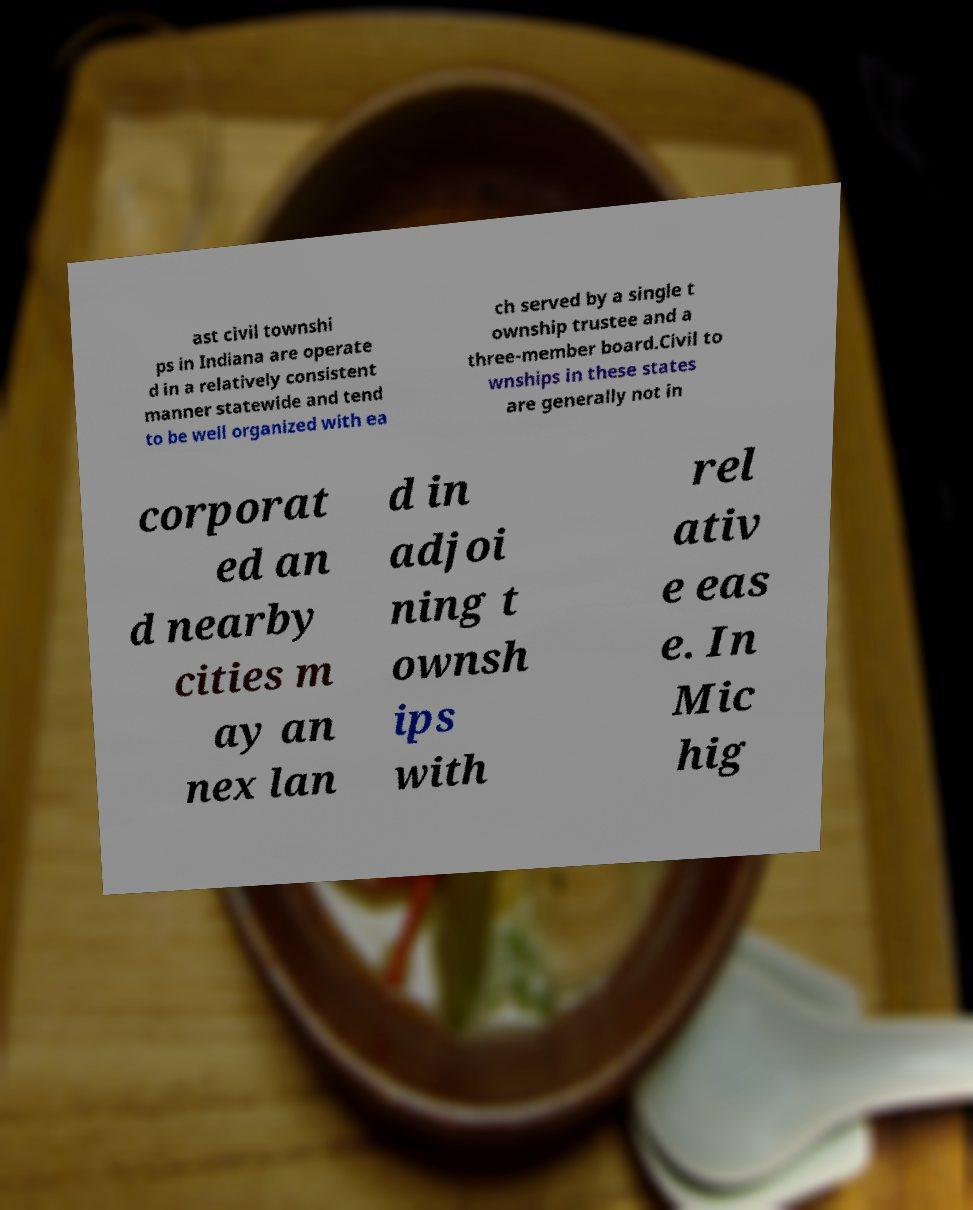Please read and relay the text visible in this image. What does it say? ast civil townshi ps in Indiana are operate d in a relatively consistent manner statewide and tend to be well organized with ea ch served by a single t ownship trustee and a three-member board.Civil to wnships in these states are generally not in corporat ed an d nearby cities m ay an nex lan d in adjoi ning t ownsh ips with rel ativ e eas e. In Mic hig 